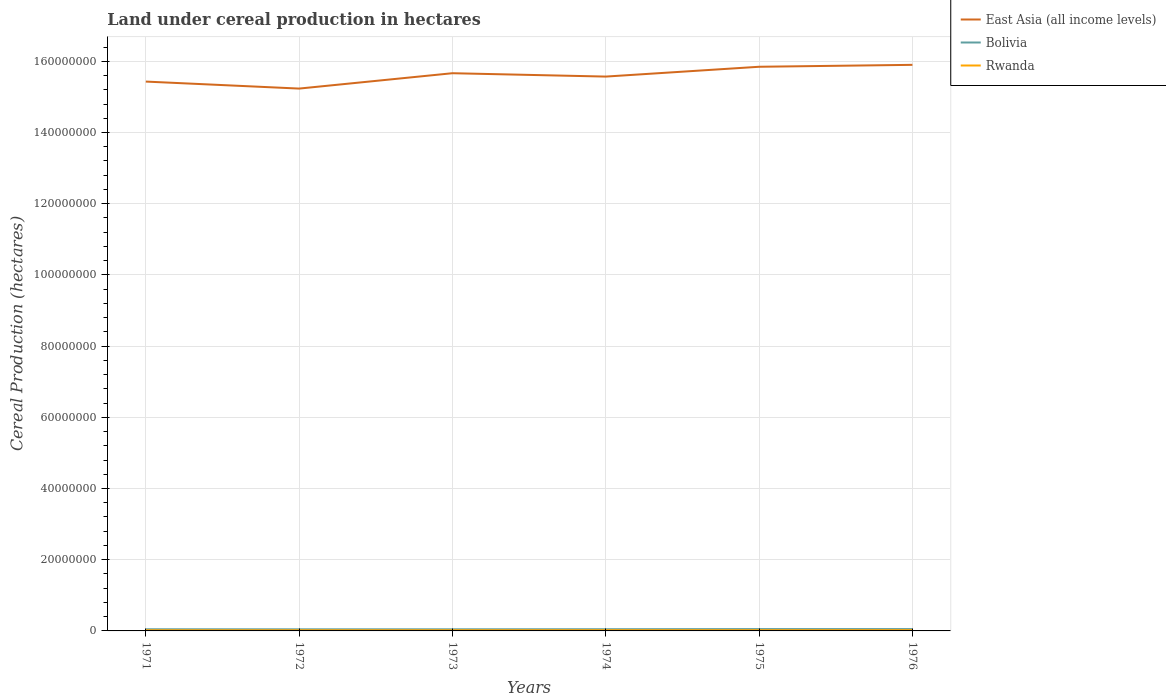Does the line corresponding to East Asia (all income levels) intersect with the line corresponding to Rwanda?
Give a very brief answer. No. Across all years, what is the maximum land under cereal production in East Asia (all income levels)?
Provide a short and direct response. 1.52e+08. What is the total land under cereal production in East Asia (all income levels) in the graph?
Ensure brevity in your answer.  -4.70e+06. What is the difference between the highest and the second highest land under cereal production in Bolivia?
Ensure brevity in your answer.  6.75e+04. Is the land under cereal production in East Asia (all income levels) strictly greater than the land under cereal production in Rwanda over the years?
Give a very brief answer. No. How many lines are there?
Provide a short and direct response. 3. How many years are there in the graph?
Offer a terse response. 6. Does the graph contain grids?
Provide a short and direct response. Yes. Where does the legend appear in the graph?
Provide a short and direct response. Top right. How many legend labels are there?
Provide a short and direct response. 3. How are the legend labels stacked?
Ensure brevity in your answer.  Vertical. What is the title of the graph?
Make the answer very short. Land under cereal production in hectares. What is the label or title of the Y-axis?
Keep it short and to the point. Cereal Production (hectares). What is the Cereal Production (hectares) in East Asia (all income levels) in 1971?
Provide a short and direct response. 1.54e+08. What is the Cereal Production (hectares) of Bolivia in 1971?
Ensure brevity in your answer.  4.63e+05. What is the Cereal Production (hectares) in Rwanda in 1971?
Keep it short and to the point. 1.88e+05. What is the Cereal Production (hectares) of East Asia (all income levels) in 1972?
Your response must be concise. 1.52e+08. What is the Cereal Production (hectares) in Bolivia in 1972?
Your answer should be very brief. 4.52e+05. What is the Cereal Production (hectares) of Rwanda in 1972?
Provide a succinct answer. 1.88e+05. What is the Cereal Production (hectares) of East Asia (all income levels) in 1973?
Your answer should be very brief. 1.57e+08. What is the Cereal Production (hectares) of Bolivia in 1973?
Offer a terse response. 4.57e+05. What is the Cereal Production (hectares) in Rwanda in 1973?
Offer a very short reply. 1.95e+05. What is the Cereal Production (hectares) of East Asia (all income levels) in 1974?
Make the answer very short. 1.56e+08. What is the Cereal Production (hectares) in Bolivia in 1974?
Offer a terse response. 4.77e+05. What is the Cereal Production (hectares) in Rwanda in 1974?
Provide a succinct answer. 2.05e+05. What is the Cereal Production (hectares) in East Asia (all income levels) in 1975?
Offer a very short reply. 1.58e+08. What is the Cereal Production (hectares) of Bolivia in 1975?
Offer a very short reply. 5.19e+05. What is the Cereal Production (hectares) in Rwanda in 1975?
Offer a very short reply. 2.04e+05. What is the Cereal Production (hectares) in East Asia (all income levels) in 1976?
Offer a very short reply. 1.59e+08. What is the Cereal Production (hectares) in Bolivia in 1976?
Keep it short and to the point. 5.17e+05. What is the Cereal Production (hectares) in Rwanda in 1976?
Offer a very short reply. 2.13e+05. Across all years, what is the maximum Cereal Production (hectares) of East Asia (all income levels)?
Provide a short and direct response. 1.59e+08. Across all years, what is the maximum Cereal Production (hectares) in Bolivia?
Offer a very short reply. 5.19e+05. Across all years, what is the maximum Cereal Production (hectares) in Rwanda?
Your answer should be compact. 2.13e+05. Across all years, what is the minimum Cereal Production (hectares) in East Asia (all income levels)?
Make the answer very short. 1.52e+08. Across all years, what is the minimum Cereal Production (hectares) in Bolivia?
Keep it short and to the point. 4.52e+05. Across all years, what is the minimum Cereal Production (hectares) of Rwanda?
Offer a terse response. 1.88e+05. What is the total Cereal Production (hectares) in East Asia (all income levels) in the graph?
Give a very brief answer. 9.36e+08. What is the total Cereal Production (hectares) in Bolivia in the graph?
Provide a succinct answer. 2.88e+06. What is the total Cereal Production (hectares) of Rwanda in the graph?
Make the answer very short. 1.19e+06. What is the difference between the Cereal Production (hectares) of East Asia (all income levels) in 1971 and that in 1972?
Your response must be concise. 1.97e+06. What is the difference between the Cereal Production (hectares) in Bolivia in 1971 and that in 1972?
Offer a terse response. 1.14e+04. What is the difference between the Cereal Production (hectares) of Rwanda in 1971 and that in 1972?
Offer a very short reply. 112. What is the difference between the Cereal Production (hectares) in East Asia (all income levels) in 1971 and that in 1973?
Your answer should be very brief. -2.35e+06. What is the difference between the Cereal Production (hectares) of Bolivia in 1971 and that in 1973?
Your answer should be compact. 6464. What is the difference between the Cereal Production (hectares) in Rwanda in 1971 and that in 1973?
Offer a terse response. -6275. What is the difference between the Cereal Production (hectares) of East Asia (all income levels) in 1971 and that in 1974?
Offer a very short reply. -1.41e+06. What is the difference between the Cereal Production (hectares) of Bolivia in 1971 and that in 1974?
Provide a succinct answer. -1.42e+04. What is the difference between the Cereal Production (hectares) of Rwanda in 1971 and that in 1974?
Give a very brief answer. -1.62e+04. What is the difference between the Cereal Production (hectares) in East Asia (all income levels) in 1971 and that in 1975?
Give a very brief answer. -4.16e+06. What is the difference between the Cereal Production (hectares) of Bolivia in 1971 and that in 1975?
Your response must be concise. -5.61e+04. What is the difference between the Cereal Production (hectares) of Rwanda in 1971 and that in 1975?
Your response must be concise. -1.57e+04. What is the difference between the Cereal Production (hectares) of East Asia (all income levels) in 1971 and that in 1976?
Offer a very short reply. -4.70e+06. What is the difference between the Cereal Production (hectares) in Bolivia in 1971 and that in 1976?
Provide a short and direct response. -5.36e+04. What is the difference between the Cereal Production (hectares) in Rwanda in 1971 and that in 1976?
Keep it short and to the point. -2.49e+04. What is the difference between the Cereal Production (hectares) in East Asia (all income levels) in 1972 and that in 1973?
Provide a short and direct response. -4.32e+06. What is the difference between the Cereal Production (hectares) in Bolivia in 1972 and that in 1973?
Give a very brief answer. -4886. What is the difference between the Cereal Production (hectares) of Rwanda in 1972 and that in 1973?
Ensure brevity in your answer.  -6387. What is the difference between the Cereal Production (hectares) of East Asia (all income levels) in 1972 and that in 1974?
Make the answer very short. -3.37e+06. What is the difference between the Cereal Production (hectares) of Bolivia in 1972 and that in 1974?
Make the answer very short. -2.56e+04. What is the difference between the Cereal Production (hectares) of Rwanda in 1972 and that in 1974?
Keep it short and to the point. -1.63e+04. What is the difference between the Cereal Production (hectares) of East Asia (all income levels) in 1972 and that in 1975?
Provide a succinct answer. -6.13e+06. What is the difference between the Cereal Production (hectares) of Bolivia in 1972 and that in 1975?
Your response must be concise. -6.75e+04. What is the difference between the Cereal Production (hectares) of Rwanda in 1972 and that in 1975?
Your answer should be compact. -1.58e+04. What is the difference between the Cereal Production (hectares) in East Asia (all income levels) in 1972 and that in 1976?
Give a very brief answer. -6.67e+06. What is the difference between the Cereal Production (hectares) in Bolivia in 1972 and that in 1976?
Your response must be concise. -6.49e+04. What is the difference between the Cereal Production (hectares) in Rwanda in 1972 and that in 1976?
Give a very brief answer. -2.50e+04. What is the difference between the Cereal Production (hectares) of East Asia (all income levels) in 1973 and that in 1974?
Ensure brevity in your answer.  9.44e+05. What is the difference between the Cereal Production (hectares) of Bolivia in 1973 and that in 1974?
Your answer should be compact. -2.07e+04. What is the difference between the Cereal Production (hectares) in Rwanda in 1973 and that in 1974?
Your answer should be very brief. -9888. What is the difference between the Cereal Production (hectares) of East Asia (all income levels) in 1973 and that in 1975?
Offer a terse response. -1.81e+06. What is the difference between the Cereal Production (hectares) of Bolivia in 1973 and that in 1975?
Make the answer very short. -6.26e+04. What is the difference between the Cereal Production (hectares) in Rwanda in 1973 and that in 1975?
Ensure brevity in your answer.  -9435. What is the difference between the Cereal Production (hectares) of East Asia (all income levels) in 1973 and that in 1976?
Offer a terse response. -2.35e+06. What is the difference between the Cereal Production (hectares) in Bolivia in 1973 and that in 1976?
Provide a succinct answer. -6.00e+04. What is the difference between the Cereal Production (hectares) of Rwanda in 1973 and that in 1976?
Your answer should be compact. -1.86e+04. What is the difference between the Cereal Production (hectares) in East Asia (all income levels) in 1974 and that in 1975?
Give a very brief answer. -2.76e+06. What is the difference between the Cereal Production (hectares) in Bolivia in 1974 and that in 1975?
Give a very brief answer. -4.19e+04. What is the difference between the Cereal Production (hectares) in Rwanda in 1974 and that in 1975?
Make the answer very short. 453. What is the difference between the Cereal Production (hectares) in East Asia (all income levels) in 1974 and that in 1976?
Offer a very short reply. -3.29e+06. What is the difference between the Cereal Production (hectares) in Bolivia in 1974 and that in 1976?
Your answer should be compact. -3.94e+04. What is the difference between the Cereal Production (hectares) in Rwanda in 1974 and that in 1976?
Offer a terse response. -8691. What is the difference between the Cereal Production (hectares) of East Asia (all income levels) in 1975 and that in 1976?
Your answer should be very brief. -5.38e+05. What is the difference between the Cereal Production (hectares) of Bolivia in 1975 and that in 1976?
Offer a terse response. 2555. What is the difference between the Cereal Production (hectares) in Rwanda in 1975 and that in 1976?
Give a very brief answer. -9144. What is the difference between the Cereal Production (hectares) of East Asia (all income levels) in 1971 and the Cereal Production (hectares) of Bolivia in 1972?
Offer a terse response. 1.54e+08. What is the difference between the Cereal Production (hectares) of East Asia (all income levels) in 1971 and the Cereal Production (hectares) of Rwanda in 1972?
Your answer should be very brief. 1.54e+08. What is the difference between the Cereal Production (hectares) in Bolivia in 1971 and the Cereal Production (hectares) in Rwanda in 1972?
Your answer should be compact. 2.75e+05. What is the difference between the Cereal Production (hectares) of East Asia (all income levels) in 1971 and the Cereal Production (hectares) of Bolivia in 1973?
Offer a very short reply. 1.54e+08. What is the difference between the Cereal Production (hectares) of East Asia (all income levels) in 1971 and the Cereal Production (hectares) of Rwanda in 1973?
Your response must be concise. 1.54e+08. What is the difference between the Cereal Production (hectares) in Bolivia in 1971 and the Cereal Production (hectares) in Rwanda in 1973?
Ensure brevity in your answer.  2.68e+05. What is the difference between the Cereal Production (hectares) of East Asia (all income levels) in 1971 and the Cereal Production (hectares) of Bolivia in 1974?
Give a very brief answer. 1.54e+08. What is the difference between the Cereal Production (hectares) of East Asia (all income levels) in 1971 and the Cereal Production (hectares) of Rwanda in 1974?
Offer a terse response. 1.54e+08. What is the difference between the Cereal Production (hectares) in Bolivia in 1971 and the Cereal Production (hectares) in Rwanda in 1974?
Offer a terse response. 2.59e+05. What is the difference between the Cereal Production (hectares) of East Asia (all income levels) in 1971 and the Cereal Production (hectares) of Bolivia in 1975?
Your answer should be compact. 1.54e+08. What is the difference between the Cereal Production (hectares) of East Asia (all income levels) in 1971 and the Cereal Production (hectares) of Rwanda in 1975?
Your response must be concise. 1.54e+08. What is the difference between the Cereal Production (hectares) in Bolivia in 1971 and the Cereal Production (hectares) in Rwanda in 1975?
Ensure brevity in your answer.  2.59e+05. What is the difference between the Cereal Production (hectares) in East Asia (all income levels) in 1971 and the Cereal Production (hectares) in Bolivia in 1976?
Your answer should be very brief. 1.54e+08. What is the difference between the Cereal Production (hectares) in East Asia (all income levels) in 1971 and the Cereal Production (hectares) in Rwanda in 1976?
Your response must be concise. 1.54e+08. What is the difference between the Cereal Production (hectares) of Bolivia in 1971 and the Cereal Production (hectares) of Rwanda in 1976?
Provide a succinct answer. 2.50e+05. What is the difference between the Cereal Production (hectares) in East Asia (all income levels) in 1972 and the Cereal Production (hectares) in Bolivia in 1973?
Keep it short and to the point. 1.52e+08. What is the difference between the Cereal Production (hectares) of East Asia (all income levels) in 1972 and the Cereal Production (hectares) of Rwanda in 1973?
Ensure brevity in your answer.  1.52e+08. What is the difference between the Cereal Production (hectares) of Bolivia in 1972 and the Cereal Production (hectares) of Rwanda in 1973?
Provide a succinct answer. 2.57e+05. What is the difference between the Cereal Production (hectares) in East Asia (all income levels) in 1972 and the Cereal Production (hectares) in Bolivia in 1974?
Keep it short and to the point. 1.52e+08. What is the difference between the Cereal Production (hectares) of East Asia (all income levels) in 1972 and the Cereal Production (hectares) of Rwanda in 1974?
Ensure brevity in your answer.  1.52e+08. What is the difference between the Cereal Production (hectares) in Bolivia in 1972 and the Cereal Production (hectares) in Rwanda in 1974?
Provide a succinct answer. 2.47e+05. What is the difference between the Cereal Production (hectares) of East Asia (all income levels) in 1972 and the Cereal Production (hectares) of Bolivia in 1975?
Offer a terse response. 1.52e+08. What is the difference between the Cereal Production (hectares) in East Asia (all income levels) in 1972 and the Cereal Production (hectares) in Rwanda in 1975?
Give a very brief answer. 1.52e+08. What is the difference between the Cereal Production (hectares) in Bolivia in 1972 and the Cereal Production (hectares) in Rwanda in 1975?
Offer a terse response. 2.48e+05. What is the difference between the Cereal Production (hectares) of East Asia (all income levels) in 1972 and the Cereal Production (hectares) of Bolivia in 1976?
Provide a short and direct response. 1.52e+08. What is the difference between the Cereal Production (hectares) of East Asia (all income levels) in 1972 and the Cereal Production (hectares) of Rwanda in 1976?
Your answer should be very brief. 1.52e+08. What is the difference between the Cereal Production (hectares) of Bolivia in 1972 and the Cereal Production (hectares) of Rwanda in 1976?
Ensure brevity in your answer.  2.38e+05. What is the difference between the Cereal Production (hectares) in East Asia (all income levels) in 1973 and the Cereal Production (hectares) in Bolivia in 1974?
Keep it short and to the point. 1.56e+08. What is the difference between the Cereal Production (hectares) of East Asia (all income levels) in 1973 and the Cereal Production (hectares) of Rwanda in 1974?
Ensure brevity in your answer.  1.56e+08. What is the difference between the Cereal Production (hectares) of Bolivia in 1973 and the Cereal Production (hectares) of Rwanda in 1974?
Ensure brevity in your answer.  2.52e+05. What is the difference between the Cereal Production (hectares) of East Asia (all income levels) in 1973 and the Cereal Production (hectares) of Bolivia in 1975?
Offer a terse response. 1.56e+08. What is the difference between the Cereal Production (hectares) of East Asia (all income levels) in 1973 and the Cereal Production (hectares) of Rwanda in 1975?
Give a very brief answer. 1.56e+08. What is the difference between the Cereal Production (hectares) of Bolivia in 1973 and the Cereal Production (hectares) of Rwanda in 1975?
Provide a short and direct response. 2.53e+05. What is the difference between the Cereal Production (hectares) in East Asia (all income levels) in 1973 and the Cereal Production (hectares) in Bolivia in 1976?
Offer a very short reply. 1.56e+08. What is the difference between the Cereal Production (hectares) in East Asia (all income levels) in 1973 and the Cereal Production (hectares) in Rwanda in 1976?
Provide a succinct answer. 1.56e+08. What is the difference between the Cereal Production (hectares) of Bolivia in 1973 and the Cereal Production (hectares) of Rwanda in 1976?
Provide a succinct answer. 2.43e+05. What is the difference between the Cereal Production (hectares) in East Asia (all income levels) in 1974 and the Cereal Production (hectares) in Bolivia in 1975?
Your answer should be compact. 1.55e+08. What is the difference between the Cereal Production (hectares) in East Asia (all income levels) in 1974 and the Cereal Production (hectares) in Rwanda in 1975?
Offer a terse response. 1.56e+08. What is the difference between the Cereal Production (hectares) of Bolivia in 1974 and the Cereal Production (hectares) of Rwanda in 1975?
Make the answer very short. 2.73e+05. What is the difference between the Cereal Production (hectares) in East Asia (all income levels) in 1974 and the Cereal Production (hectares) in Bolivia in 1976?
Your response must be concise. 1.55e+08. What is the difference between the Cereal Production (hectares) in East Asia (all income levels) in 1974 and the Cereal Production (hectares) in Rwanda in 1976?
Provide a short and direct response. 1.55e+08. What is the difference between the Cereal Production (hectares) of Bolivia in 1974 and the Cereal Production (hectares) of Rwanda in 1976?
Give a very brief answer. 2.64e+05. What is the difference between the Cereal Production (hectares) in East Asia (all income levels) in 1975 and the Cereal Production (hectares) in Bolivia in 1976?
Your answer should be compact. 1.58e+08. What is the difference between the Cereal Production (hectares) of East Asia (all income levels) in 1975 and the Cereal Production (hectares) of Rwanda in 1976?
Offer a very short reply. 1.58e+08. What is the difference between the Cereal Production (hectares) in Bolivia in 1975 and the Cereal Production (hectares) in Rwanda in 1976?
Keep it short and to the point. 3.06e+05. What is the average Cereal Production (hectares) in East Asia (all income levels) per year?
Keep it short and to the point. 1.56e+08. What is the average Cereal Production (hectares) in Bolivia per year?
Offer a terse response. 4.81e+05. What is the average Cereal Production (hectares) in Rwanda per year?
Provide a succinct answer. 1.99e+05. In the year 1971, what is the difference between the Cereal Production (hectares) of East Asia (all income levels) and Cereal Production (hectares) of Bolivia?
Offer a very short reply. 1.54e+08. In the year 1971, what is the difference between the Cereal Production (hectares) in East Asia (all income levels) and Cereal Production (hectares) in Rwanda?
Your answer should be very brief. 1.54e+08. In the year 1971, what is the difference between the Cereal Production (hectares) of Bolivia and Cereal Production (hectares) of Rwanda?
Make the answer very short. 2.75e+05. In the year 1972, what is the difference between the Cereal Production (hectares) of East Asia (all income levels) and Cereal Production (hectares) of Bolivia?
Give a very brief answer. 1.52e+08. In the year 1972, what is the difference between the Cereal Production (hectares) in East Asia (all income levels) and Cereal Production (hectares) in Rwanda?
Provide a short and direct response. 1.52e+08. In the year 1972, what is the difference between the Cereal Production (hectares) of Bolivia and Cereal Production (hectares) of Rwanda?
Your answer should be compact. 2.63e+05. In the year 1973, what is the difference between the Cereal Production (hectares) of East Asia (all income levels) and Cereal Production (hectares) of Bolivia?
Offer a terse response. 1.56e+08. In the year 1973, what is the difference between the Cereal Production (hectares) of East Asia (all income levels) and Cereal Production (hectares) of Rwanda?
Ensure brevity in your answer.  1.56e+08. In the year 1973, what is the difference between the Cereal Production (hectares) of Bolivia and Cereal Production (hectares) of Rwanda?
Offer a terse response. 2.62e+05. In the year 1974, what is the difference between the Cereal Production (hectares) of East Asia (all income levels) and Cereal Production (hectares) of Bolivia?
Ensure brevity in your answer.  1.55e+08. In the year 1974, what is the difference between the Cereal Production (hectares) of East Asia (all income levels) and Cereal Production (hectares) of Rwanda?
Your answer should be compact. 1.56e+08. In the year 1974, what is the difference between the Cereal Production (hectares) in Bolivia and Cereal Production (hectares) in Rwanda?
Your answer should be compact. 2.73e+05. In the year 1975, what is the difference between the Cereal Production (hectares) in East Asia (all income levels) and Cereal Production (hectares) in Bolivia?
Make the answer very short. 1.58e+08. In the year 1975, what is the difference between the Cereal Production (hectares) of East Asia (all income levels) and Cereal Production (hectares) of Rwanda?
Ensure brevity in your answer.  1.58e+08. In the year 1975, what is the difference between the Cereal Production (hectares) of Bolivia and Cereal Production (hectares) of Rwanda?
Provide a succinct answer. 3.15e+05. In the year 1976, what is the difference between the Cereal Production (hectares) of East Asia (all income levels) and Cereal Production (hectares) of Bolivia?
Give a very brief answer. 1.58e+08. In the year 1976, what is the difference between the Cereal Production (hectares) of East Asia (all income levels) and Cereal Production (hectares) of Rwanda?
Provide a short and direct response. 1.59e+08. In the year 1976, what is the difference between the Cereal Production (hectares) in Bolivia and Cereal Production (hectares) in Rwanda?
Your answer should be compact. 3.03e+05. What is the ratio of the Cereal Production (hectares) of East Asia (all income levels) in 1971 to that in 1972?
Your response must be concise. 1.01. What is the ratio of the Cereal Production (hectares) of Bolivia in 1971 to that in 1972?
Your answer should be very brief. 1.03. What is the ratio of the Cereal Production (hectares) of Rwanda in 1971 to that in 1972?
Offer a very short reply. 1. What is the ratio of the Cereal Production (hectares) of Bolivia in 1971 to that in 1973?
Provide a succinct answer. 1.01. What is the ratio of the Cereal Production (hectares) in Rwanda in 1971 to that in 1973?
Keep it short and to the point. 0.97. What is the ratio of the Cereal Production (hectares) of East Asia (all income levels) in 1971 to that in 1974?
Offer a very short reply. 0.99. What is the ratio of the Cereal Production (hectares) of Bolivia in 1971 to that in 1974?
Keep it short and to the point. 0.97. What is the ratio of the Cereal Production (hectares) of Rwanda in 1971 to that in 1974?
Provide a short and direct response. 0.92. What is the ratio of the Cereal Production (hectares) in East Asia (all income levels) in 1971 to that in 1975?
Keep it short and to the point. 0.97. What is the ratio of the Cereal Production (hectares) in Bolivia in 1971 to that in 1975?
Your answer should be compact. 0.89. What is the ratio of the Cereal Production (hectares) of Rwanda in 1971 to that in 1975?
Ensure brevity in your answer.  0.92. What is the ratio of the Cereal Production (hectares) of East Asia (all income levels) in 1971 to that in 1976?
Your response must be concise. 0.97. What is the ratio of the Cereal Production (hectares) of Bolivia in 1971 to that in 1976?
Provide a short and direct response. 0.9. What is the ratio of the Cereal Production (hectares) in Rwanda in 1971 to that in 1976?
Make the answer very short. 0.88. What is the ratio of the Cereal Production (hectares) of East Asia (all income levels) in 1972 to that in 1973?
Your response must be concise. 0.97. What is the ratio of the Cereal Production (hectares) in Bolivia in 1972 to that in 1973?
Keep it short and to the point. 0.99. What is the ratio of the Cereal Production (hectares) of Rwanda in 1972 to that in 1973?
Offer a terse response. 0.97. What is the ratio of the Cereal Production (hectares) of East Asia (all income levels) in 1972 to that in 1974?
Keep it short and to the point. 0.98. What is the ratio of the Cereal Production (hectares) of Bolivia in 1972 to that in 1974?
Offer a terse response. 0.95. What is the ratio of the Cereal Production (hectares) of Rwanda in 1972 to that in 1974?
Offer a terse response. 0.92. What is the ratio of the Cereal Production (hectares) in East Asia (all income levels) in 1972 to that in 1975?
Provide a short and direct response. 0.96. What is the ratio of the Cereal Production (hectares) in Bolivia in 1972 to that in 1975?
Provide a succinct answer. 0.87. What is the ratio of the Cereal Production (hectares) of Rwanda in 1972 to that in 1975?
Ensure brevity in your answer.  0.92. What is the ratio of the Cereal Production (hectares) in East Asia (all income levels) in 1972 to that in 1976?
Your answer should be very brief. 0.96. What is the ratio of the Cereal Production (hectares) in Bolivia in 1972 to that in 1976?
Offer a very short reply. 0.87. What is the ratio of the Cereal Production (hectares) of Rwanda in 1972 to that in 1976?
Your answer should be very brief. 0.88. What is the ratio of the Cereal Production (hectares) in Bolivia in 1973 to that in 1974?
Give a very brief answer. 0.96. What is the ratio of the Cereal Production (hectares) of Rwanda in 1973 to that in 1974?
Provide a short and direct response. 0.95. What is the ratio of the Cereal Production (hectares) in East Asia (all income levels) in 1973 to that in 1975?
Your response must be concise. 0.99. What is the ratio of the Cereal Production (hectares) of Bolivia in 1973 to that in 1975?
Your response must be concise. 0.88. What is the ratio of the Cereal Production (hectares) of Rwanda in 1973 to that in 1975?
Provide a succinct answer. 0.95. What is the ratio of the Cereal Production (hectares) of East Asia (all income levels) in 1973 to that in 1976?
Offer a very short reply. 0.99. What is the ratio of the Cereal Production (hectares) of Bolivia in 1973 to that in 1976?
Keep it short and to the point. 0.88. What is the ratio of the Cereal Production (hectares) in Rwanda in 1973 to that in 1976?
Provide a short and direct response. 0.91. What is the ratio of the Cereal Production (hectares) of East Asia (all income levels) in 1974 to that in 1975?
Give a very brief answer. 0.98. What is the ratio of the Cereal Production (hectares) in Bolivia in 1974 to that in 1975?
Keep it short and to the point. 0.92. What is the ratio of the Cereal Production (hectares) of East Asia (all income levels) in 1974 to that in 1976?
Keep it short and to the point. 0.98. What is the ratio of the Cereal Production (hectares) in Bolivia in 1974 to that in 1976?
Provide a short and direct response. 0.92. What is the ratio of the Cereal Production (hectares) in Rwanda in 1974 to that in 1976?
Give a very brief answer. 0.96. What is the ratio of the Cereal Production (hectares) of Bolivia in 1975 to that in 1976?
Your answer should be compact. 1. What is the ratio of the Cereal Production (hectares) in Rwanda in 1975 to that in 1976?
Your response must be concise. 0.96. What is the difference between the highest and the second highest Cereal Production (hectares) in East Asia (all income levels)?
Your response must be concise. 5.38e+05. What is the difference between the highest and the second highest Cereal Production (hectares) of Bolivia?
Provide a succinct answer. 2555. What is the difference between the highest and the second highest Cereal Production (hectares) in Rwanda?
Make the answer very short. 8691. What is the difference between the highest and the lowest Cereal Production (hectares) in East Asia (all income levels)?
Keep it short and to the point. 6.67e+06. What is the difference between the highest and the lowest Cereal Production (hectares) of Bolivia?
Provide a short and direct response. 6.75e+04. What is the difference between the highest and the lowest Cereal Production (hectares) of Rwanda?
Provide a succinct answer. 2.50e+04. 